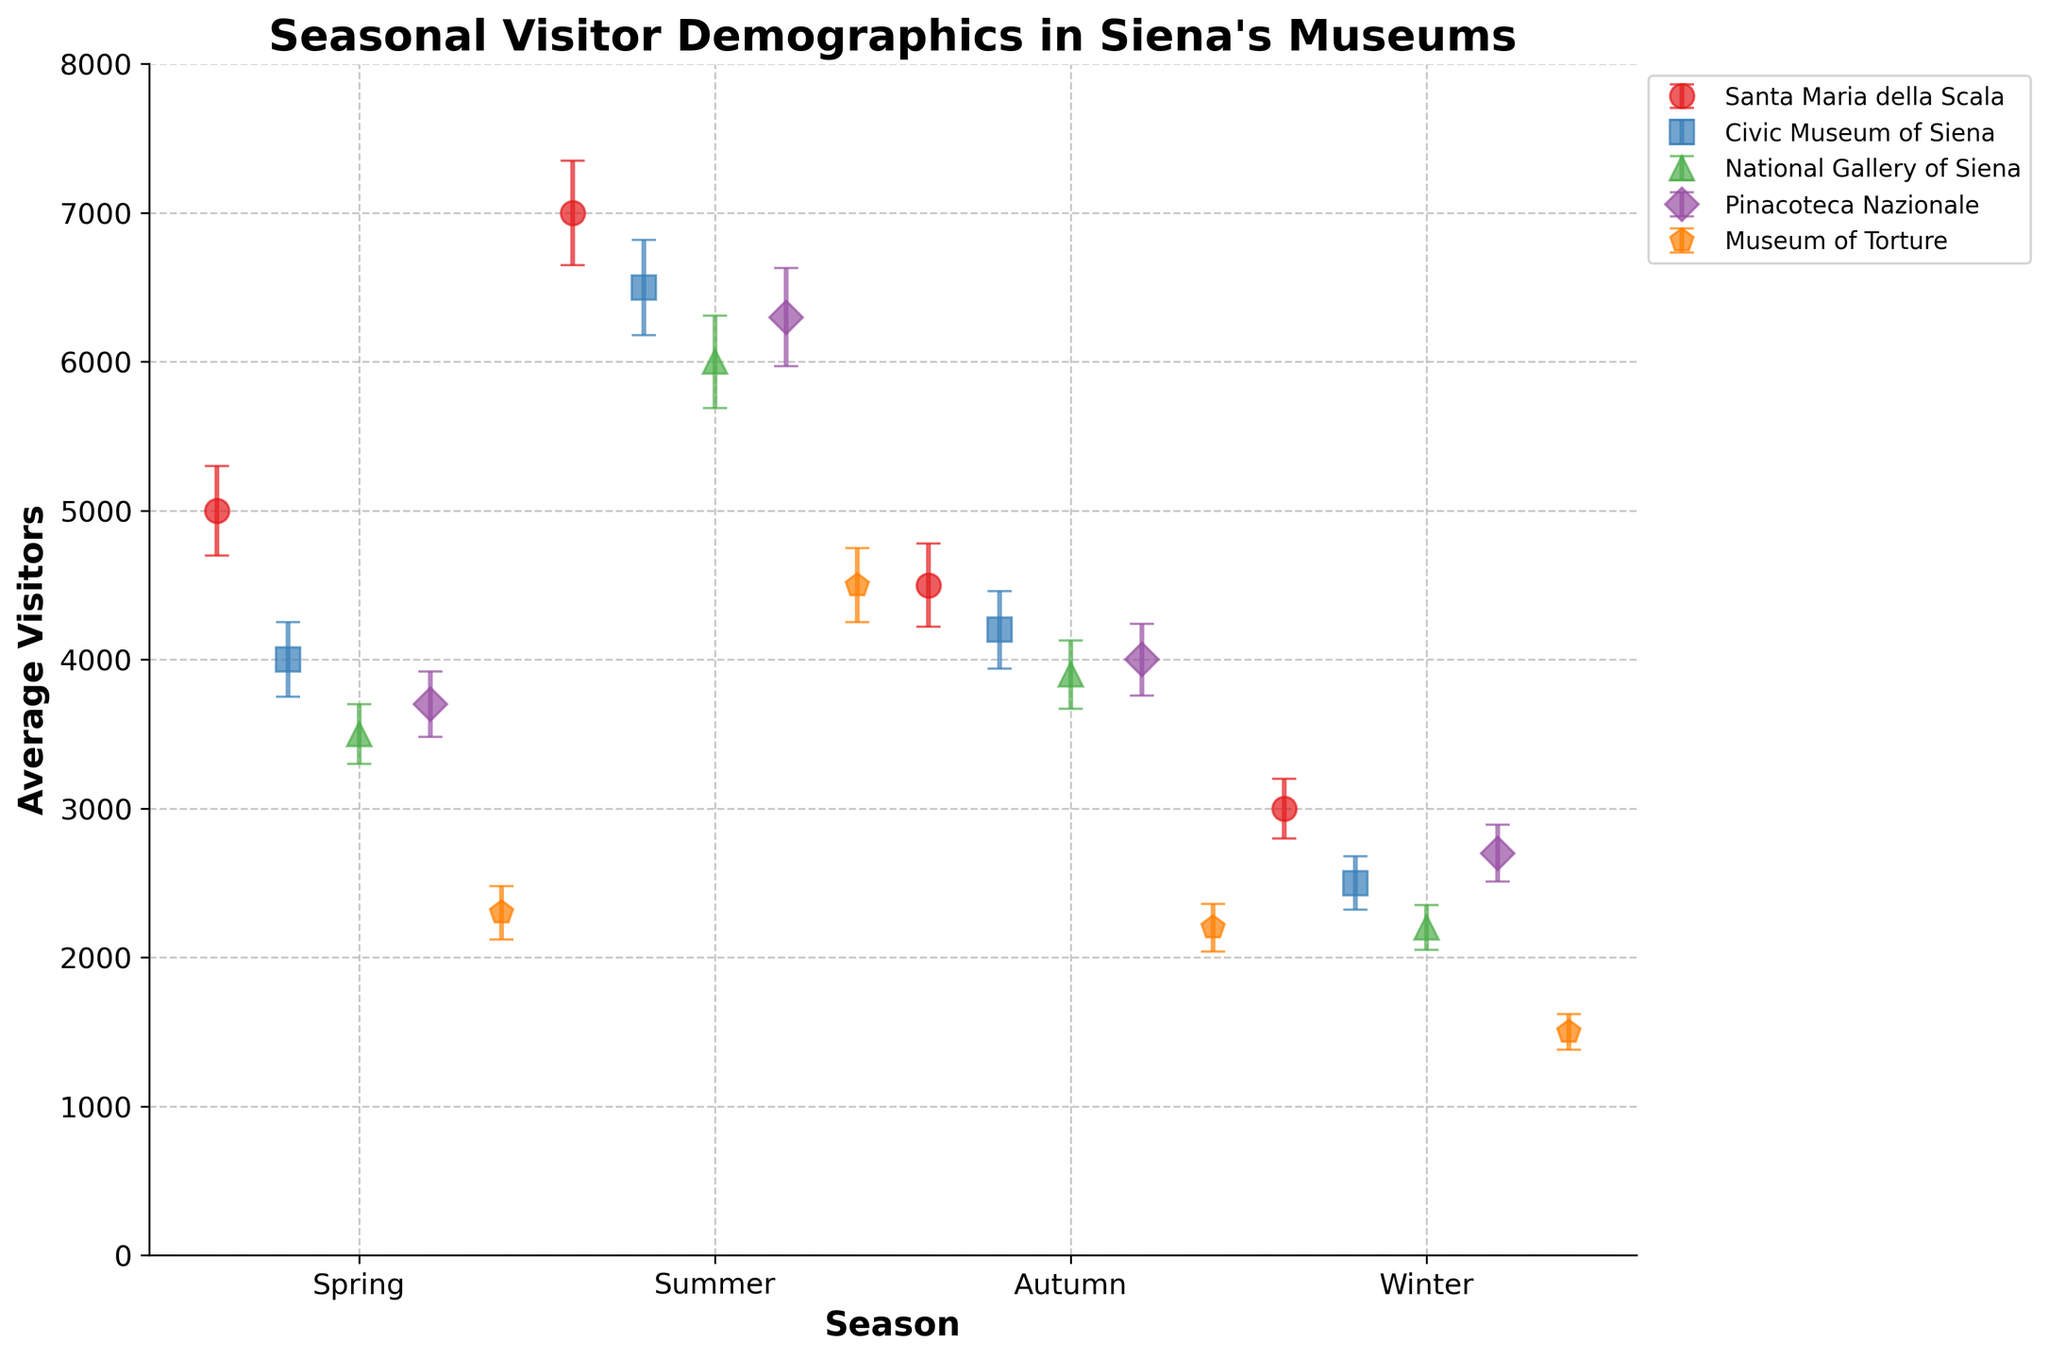What's the title of the figure? The title is usually displayed at the top of the figure. In this case, it is clearly visible and labeled as "Seasonal Visitor Demographics in Siena's Museums."
Answer: Seasonal Visitor Demographics in Siena's Museums Which museum had the highest average visitors in summer? To answer this, locate the summer data points for all museums, compare their average visitors, and identify the highest value. Santa Maria della Scala reaches 7000, which is the highest.
Answer: Santa Maria della Scala What is the range of average visitors for the National Gallery of Siena across all seasons? The range can be calculated as the difference between the maximum and minimum average visitors. For the National Gallery of Siena, the maximum is 6000 (Summer) and the minimum is 2200 (Winter). The range is 6000 - 2200 = 3800.
Answer: 3800 How does the average number of visitors in winter at the Civic Museum of Siena compare to the other museums? By examining the winter data points, Civic Museum of Siena has 2500 visitors. Santa Maria della Scala has 3000 visitors, National Gallery of Siena has 2200, Pinacoteca Nazionale has 2700, and Museum of Torture has 1500. The Civic Museum has fewer visitors compared to Santa Maria della Scala and Pinacoteca Nazionale but more than National Gallery and Museum of Torture.
Answer: Lower than Santa Maria della Scala and Pinacoteca Nazionale, higher than National Gallery of Siena and Museum of Torture What's the difference in the average number of visitors between Spring and Autumn for Pinacoteca Nazionale? For Pinacoteca Nazionale, the average number of visitors in Spring is 3700 and in Autumn is 4000. The difference is 4000 - 3700 = 300.
Answer: 300 In which season does the Museum of Torture see the greatest variation in visitors? Variation is represented by the standard deviation. For the Museum of Torture, comparing standard deviations across seasons: Spring (180), Summer (250), Autumn (160), Winter (120). Summer has the highest standard deviation of 250.
Answer: Summer Which museum has the smallest average visitor count in autumn? To find the answer, look at the autumn data points and find the one with the smallest value. The Museum of Torture has the smallest average visitor count with 2200.
Answer: Museum of Torture What is the combined average visitor count for Santa Maria della Scala and Civic Museum of Siena in summer? Add the average visitor counts for Santa Maria della Scala (7000) and Civic Museum of Siena (6500) in summer. 7000 + 6500 = 13500.
Answer: 13500 Plot-wise, how are the errors represented and what does it indicate? Errors are shown as vertical lines with caps (error bars) extending from the dots. These represent the standard deviation, indicating the variability around the average visitor count. Larger error bars imply higher variability.
Answer: Error bars with caps, representing standard deviation 